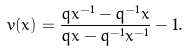Convert formula to latex. <formula><loc_0><loc_0><loc_500><loc_500>v ( x ) = \frac { q x ^ { - 1 } - q ^ { - 1 } x } { q x - q ^ { - 1 } x ^ { - 1 } } - 1 .</formula> 